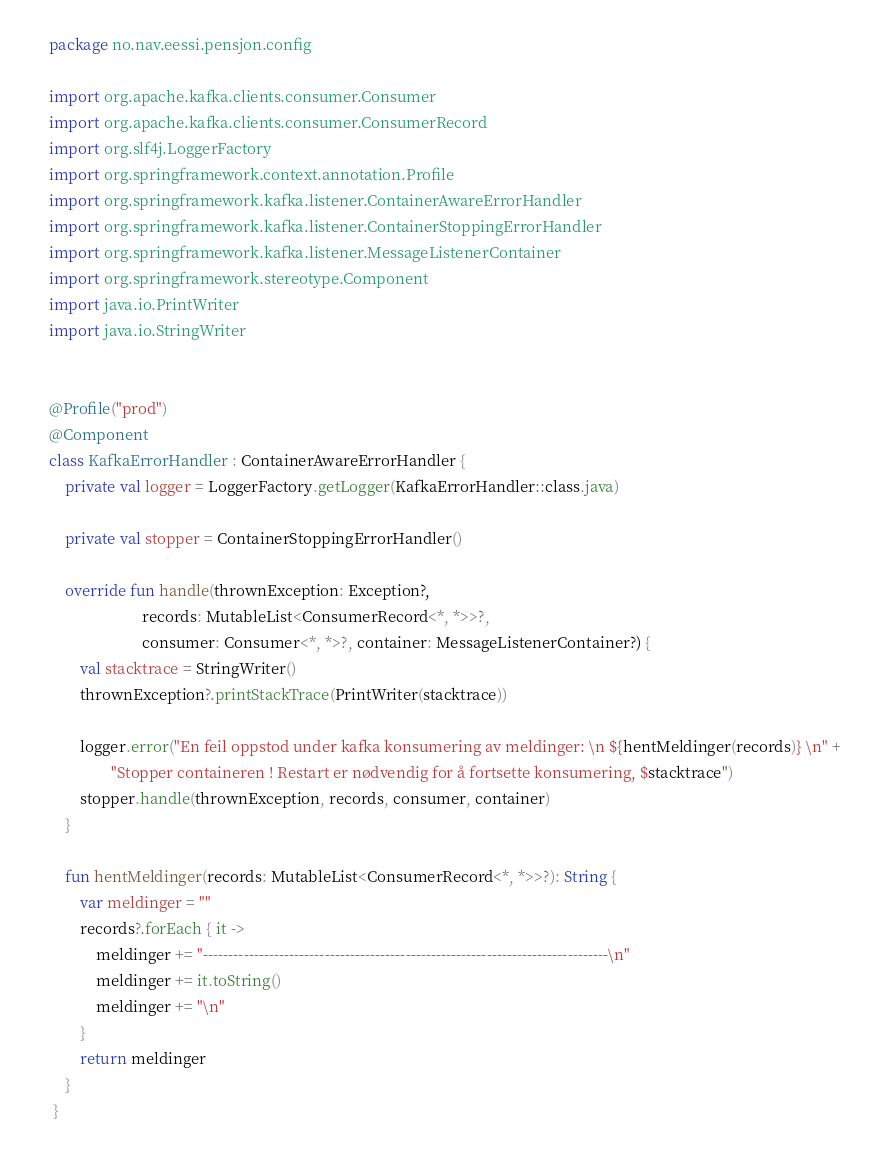<code> <loc_0><loc_0><loc_500><loc_500><_Kotlin_>package no.nav.eessi.pensjon.config

import org.apache.kafka.clients.consumer.Consumer
import org.apache.kafka.clients.consumer.ConsumerRecord
import org.slf4j.LoggerFactory
import org.springframework.context.annotation.Profile
import org.springframework.kafka.listener.ContainerAwareErrorHandler
import org.springframework.kafka.listener.ContainerStoppingErrorHandler
import org.springframework.kafka.listener.MessageListenerContainer
import org.springframework.stereotype.Component
import java.io.PrintWriter
import java.io.StringWriter


@Profile("prod")
@Component
class KafkaErrorHandler : ContainerAwareErrorHandler {
    private val logger = LoggerFactory.getLogger(KafkaErrorHandler::class.java)

    private val stopper = ContainerStoppingErrorHandler()

    override fun handle(thrownException: Exception?,
                        records: MutableList<ConsumerRecord<*, *>>?,
                        consumer: Consumer<*, *>?, container: MessageListenerContainer?) {
        val stacktrace = StringWriter()
        thrownException?.printStackTrace(PrintWriter(stacktrace))

        logger.error("En feil oppstod under kafka konsumering av meldinger: \n ${hentMeldinger(records)} \n" +
                "Stopper containeren ! Restart er nødvendig for å fortsette konsumering, $stacktrace")
        stopper.handle(thrownException, records, consumer, container)
    }

    fun hentMeldinger(records: MutableList<ConsumerRecord<*, *>>?): String {
        var meldinger = ""
        records?.forEach { it ->
            meldinger += "--------------------------------------------------------------------------------\n"
            meldinger += it.toString()
            meldinger += "\n"
        }
        return meldinger
    }
 }
</code> 